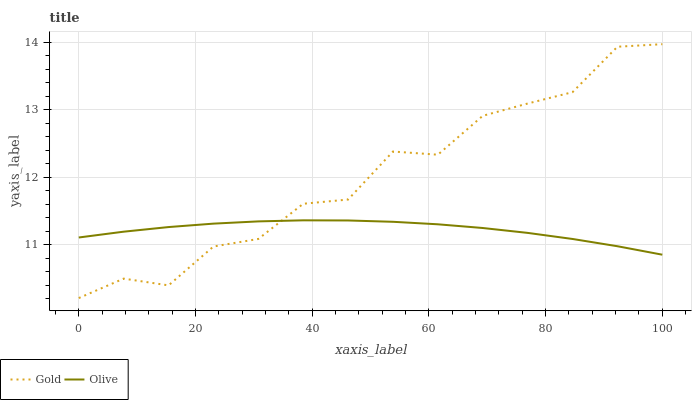Does Olive have the minimum area under the curve?
Answer yes or no. Yes. Does Gold have the maximum area under the curve?
Answer yes or no. Yes. Does Gold have the minimum area under the curve?
Answer yes or no. No. Is Olive the smoothest?
Answer yes or no. Yes. Is Gold the roughest?
Answer yes or no. Yes. Is Gold the smoothest?
Answer yes or no. No. 